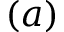<formula> <loc_0><loc_0><loc_500><loc_500>( a )</formula> 